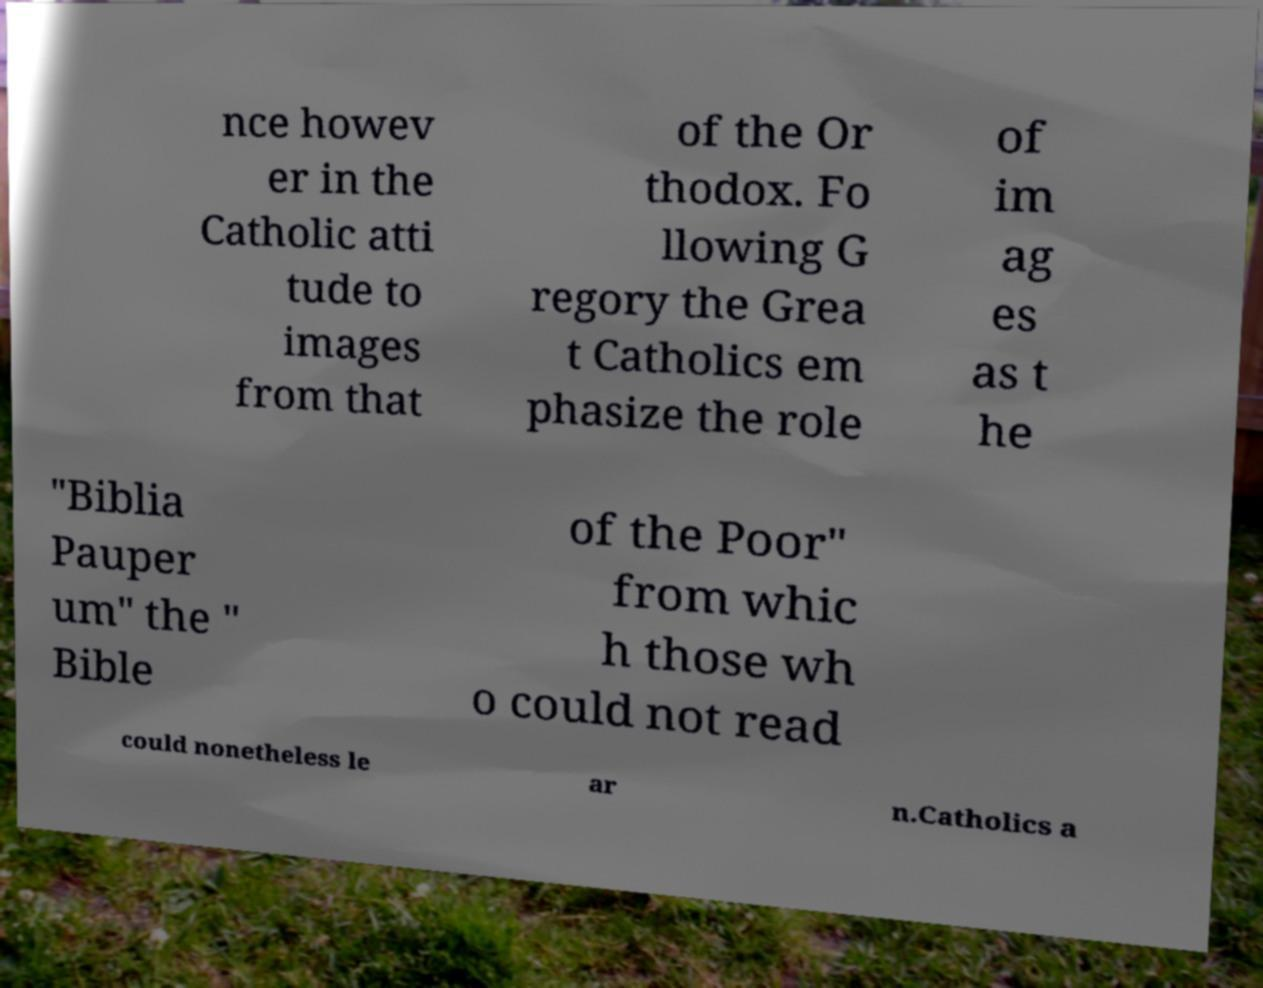Can you accurately transcribe the text from the provided image for me? nce howev er in the Catholic atti tude to images from that of the Or thodox. Fo llowing G regory the Grea t Catholics em phasize the role of im ag es as t he "Biblia Pauper um" the " Bible of the Poor" from whic h those wh o could not read could nonetheless le ar n.Catholics a 